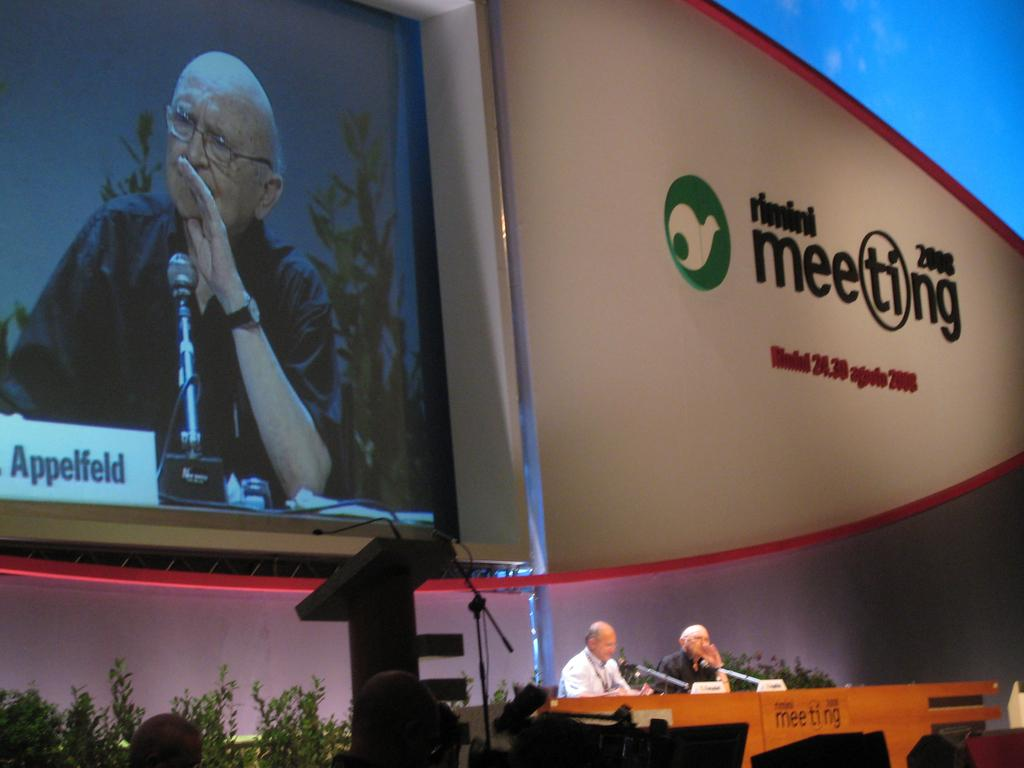<image>
Describe the image concisely. Two men giving a presentation at Rimini Meeeting 2008. 